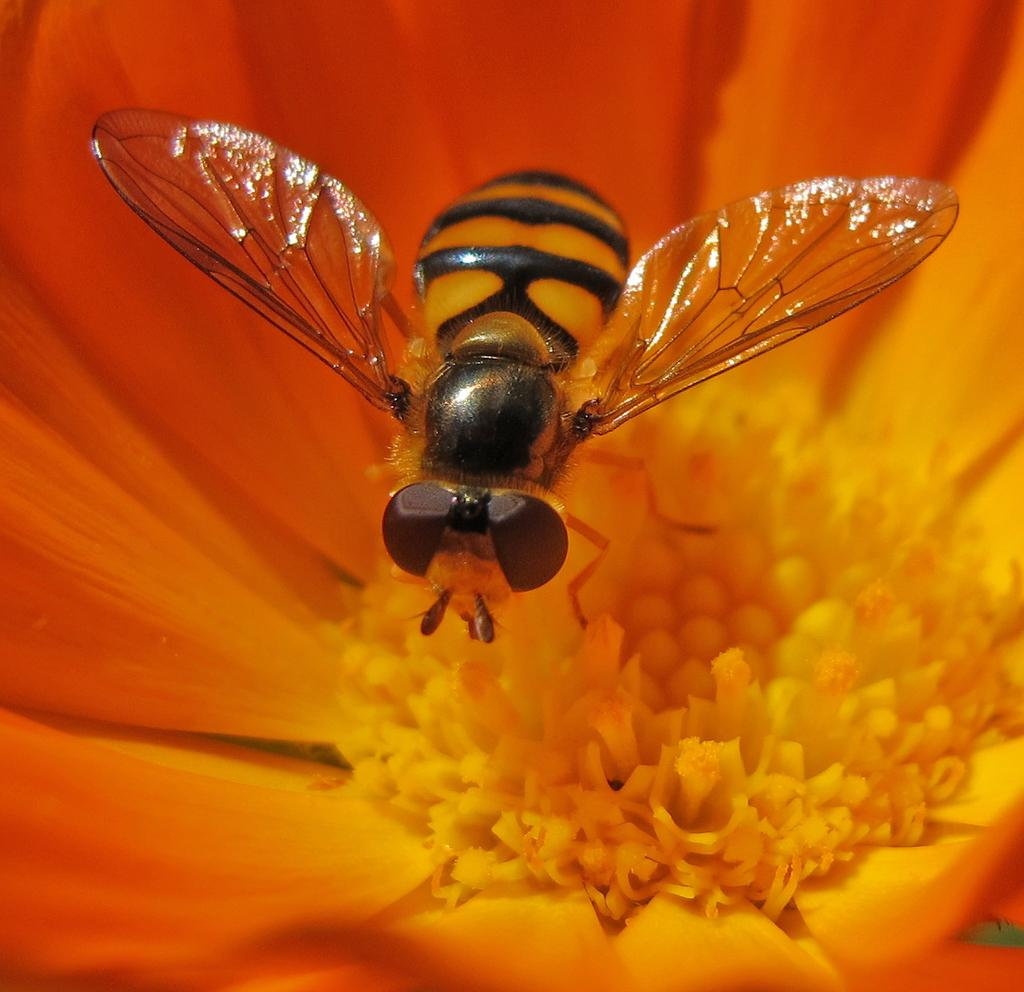What is the main subject of the image? There is a flower in the image. Is there anything interacting with the flower? Yes, there is a honey bee on the flower. What type of drug is being used by the honey bee in the image? There is no drug present in the image; it features a flower with a honey bee on it. What type of fuel is being used by the honey bee in the image? Honey bees do not use fuel; they obtain energy from nectar and pollen. 